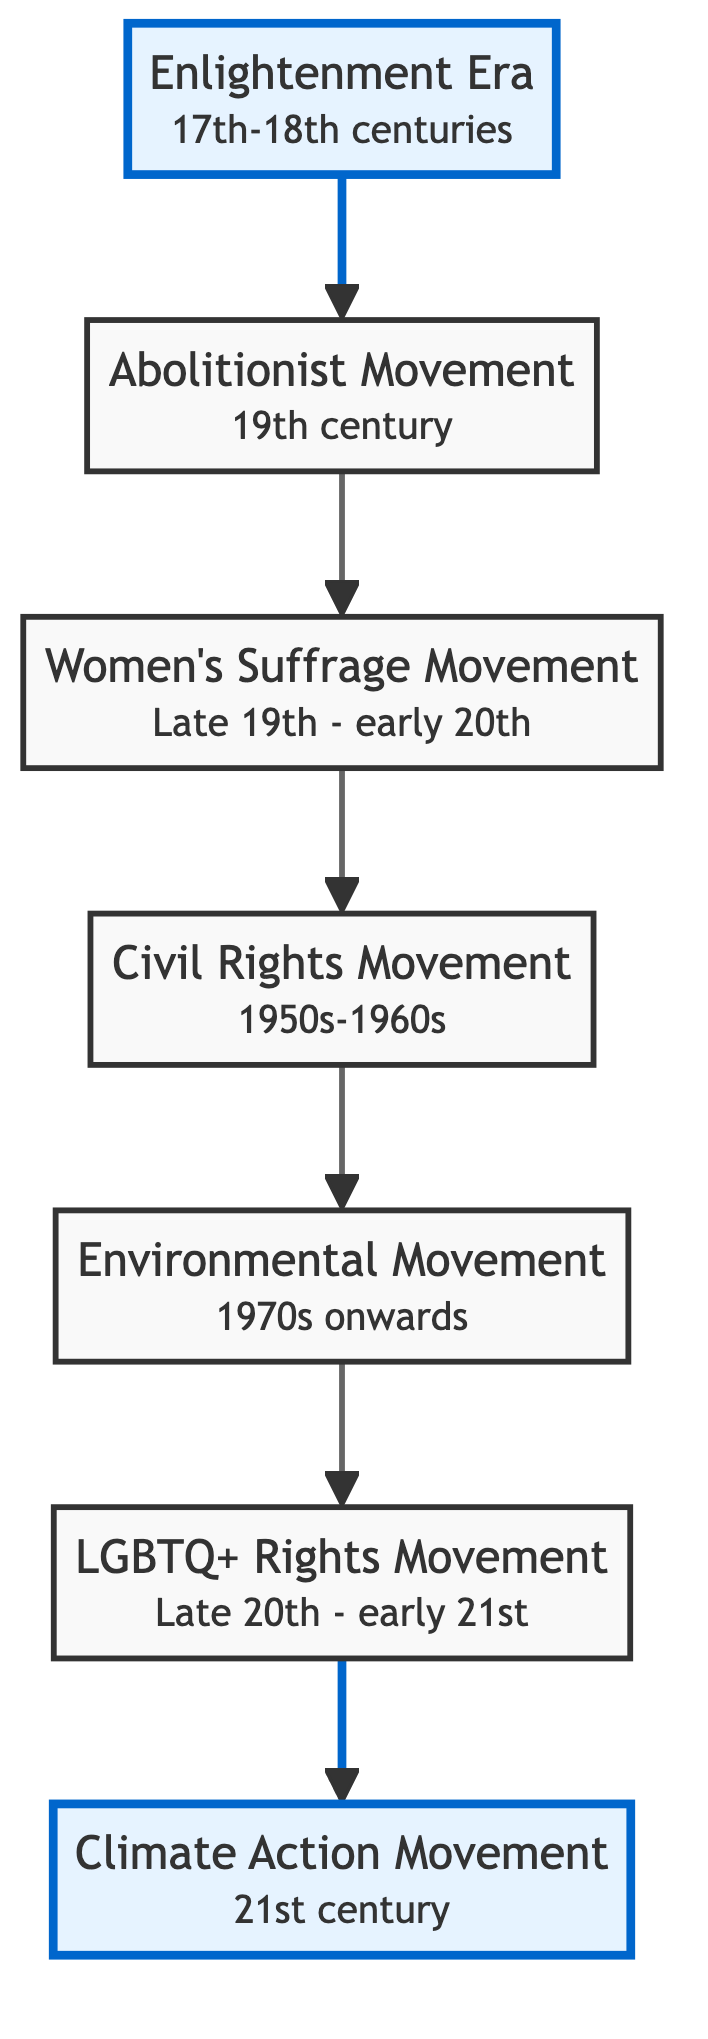What is the last movement shown in the diagram? The diagram flows from bottom to top, ending with the "Climate Action Movement" at the top-most position.
Answer: Climate Action Movement How many movements are listed in the diagram? Counting each movement from the "Enlightenment Era" to the "Climate Action Movement," there are a total of seven distinct movements represented.
Answer: 7 Which movement directly follows the Civil Rights Movement? To find the movement that follows "Civil Rights Movement," we look at the diagram's upward flow, where the next node above is "Environmental Movement."
Answer: Environmental Movement What century did the Abolitionist Movement occur in? The diagram specifies that the "Abolitionist Movement" took place in the 19th century, as indicated in its description.
Answer: 19th century How does the Women's Suffrage Movement relate to the Enlightenment Era? The "Women's Suffrage Movement" comes directly after the "Abolitionist Movement," which is indicated to have been inspired by ideas that can be traced back to the "Enlightenment Era," showcasing a flow of influence over time.
Answer: Influence from Enlightenment Era What is the first movement described in the diagram? The very first movement listed at the bottom of the diagram is the "Enlightenment Era," which sets the stage for subsequent movements.
Answer: Enlightenment Era Name one key figure associated with the LGBTQ+ Rights Movement. The diagram does not explicitly list figures, but historical context informs us that pivotal events like the Stonewall Riots prominently featured activists such as Harvey Milk.
Answer: Harvey Milk What significant event is associated with the Environmental Movement? The description of the "Environmental Movement" highlights initiatives like Earth Day, which serves as a critical event in raising awareness regarding environmental issues.
Answer: Earth Day Which movement is characterized by psychological research on sexual orientation? The "LGBTQ+ Rights Movement" is notably supported by psychological research on sexual orientation and gender identity, reflecting the theoretical basis for advocacy.
Answer: LGBTQ+ Rights Movement 